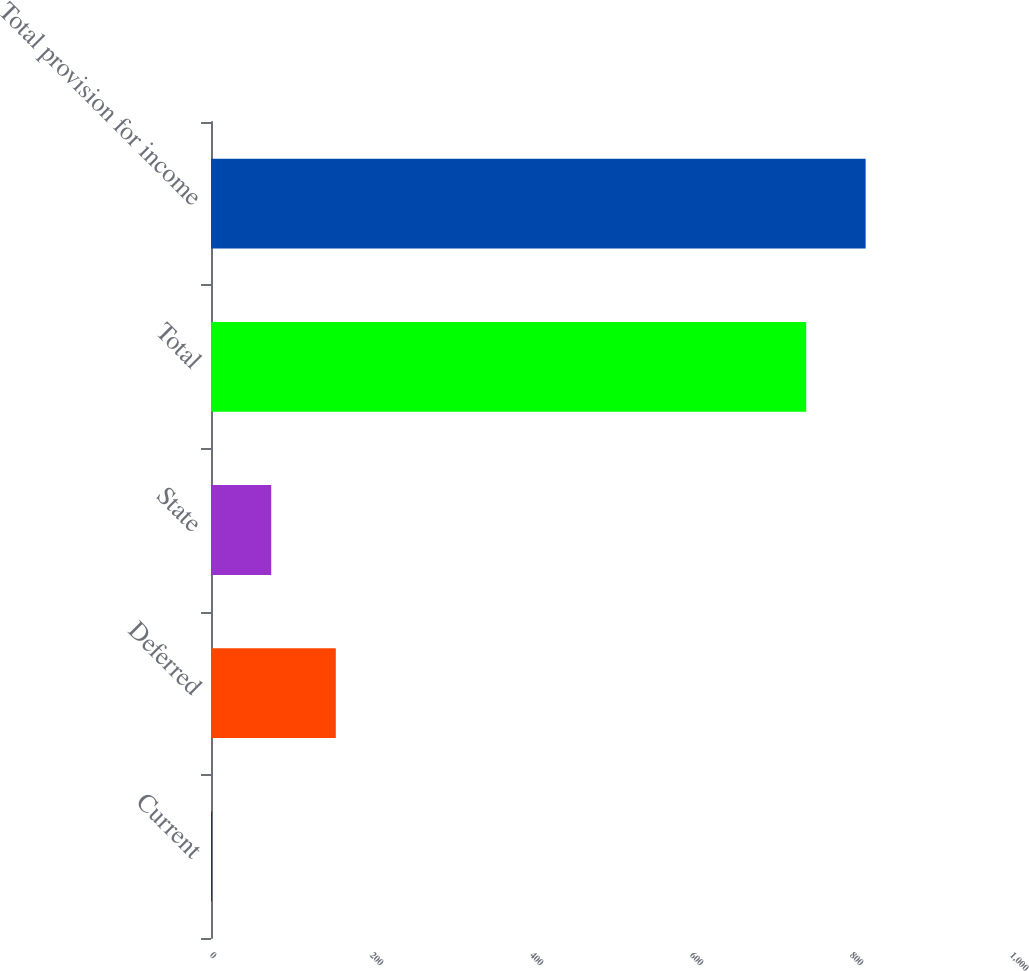<chart> <loc_0><loc_0><loc_500><loc_500><bar_chart><fcel>Current<fcel>Deferred<fcel>State<fcel>Total<fcel>Total provision for income<nl><fcel>1<fcel>156<fcel>75.3<fcel>744<fcel>818.3<nl></chart> 